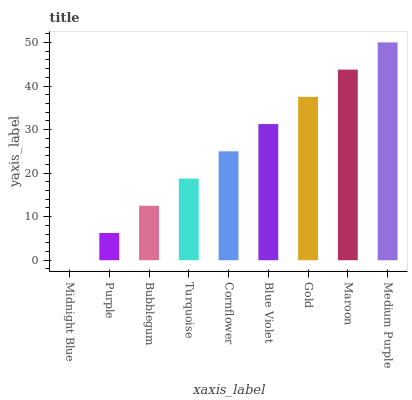Is Midnight Blue the minimum?
Answer yes or no. Yes. Is Medium Purple the maximum?
Answer yes or no. Yes. Is Purple the minimum?
Answer yes or no. No. Is Purple the maximum?
Answer yes or no. No. Is Purple greater than Midnight Blue?
Answer yes or no. Yes. Is Midnight Blue less than Purple?
Answer yes or no. Yes. Is Midnight Blue greater than Purple?
Answer yes or no. No. Is Purple less than Midnight Blue?
Answer yes or no. No. Is Cornflower the high median?
Answer yes or no. Yes. Is Cornflower the low median?
Answer yes or no. Yes. Is Gold the high median?
Answer yes or no. No. Is Purple the low median?
Answer yes or no. No. 